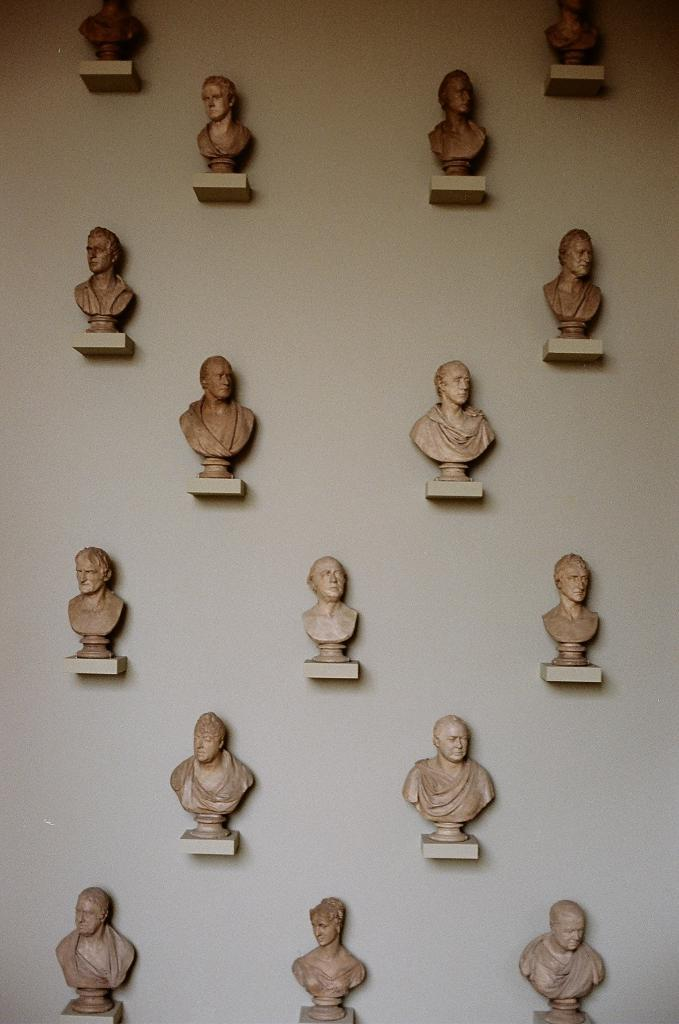What is depicted on the wall in the image? There are statues on the wall in the image. What invention can be seen in the image that helps people escape from quicksand? There is no invention or reference to quicksand present in the image; it only features statues on the wall. 